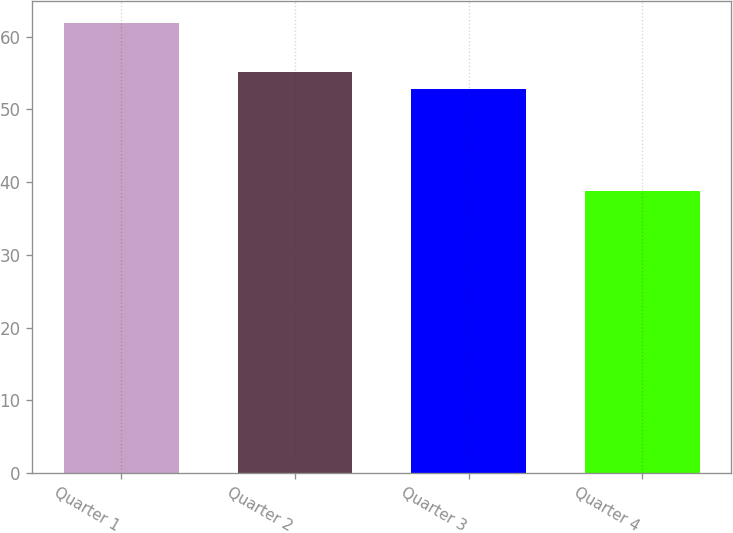Convert chart. <chart><loc_0><loc_0><loc_500><loc_500><bar_chart><fcel>Quarter 1<fcel>Quarter 2<fcel>Quarter 3<fcel>Quarter 4<nl><fcel>61.88<fcel>55.09<fcel>52.78<fcel>38.81<nl></chart> 